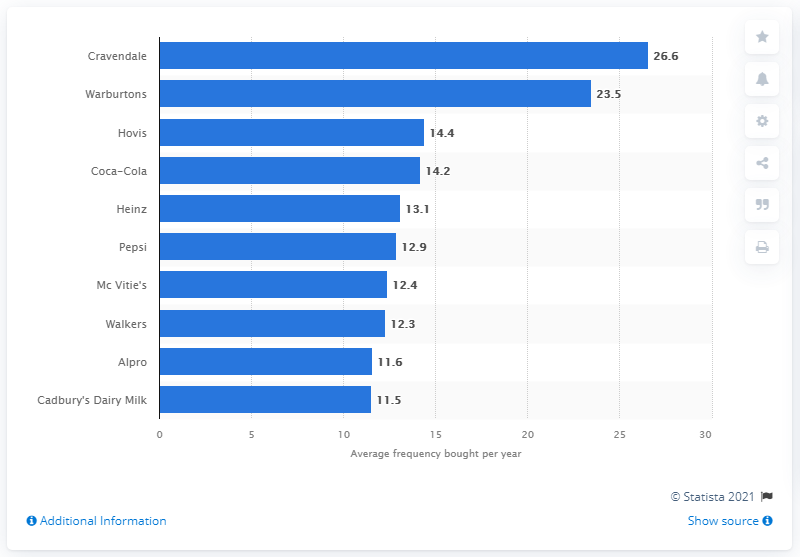Draw attention to some important aspects in this diagram. Cravendale was the brand that was most frequently purchased by households in the UK in 2020, according to data. 